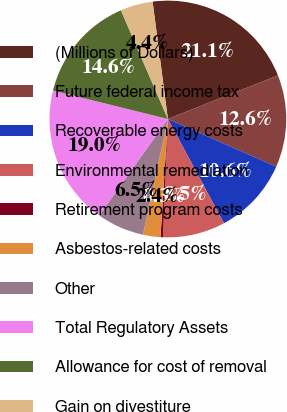Convert chart. <chart><loc_0><loc_0><loc_500><loc_500><pie_chart><fcel>(Millions of Dollars)<fcel>Future federal income tax<fcel>Recoverable energy costs<fcel>Environmental remediation<fcel>Retirement program costs<fcel>Asbestos-related costs<fcel>Other<fcel>Total Regulatory Assets<fcel>Allowance for cost of removal<fcel>Gain on divestiture<nl><fcel>21.06%<fcel>12.59%<fcel>10.55%<fcel>8.51%<fcel>0.34%<fcel>2.38%<fcel>6.47%<fcel>19.02%<fcel>14.64%<fcel>4.43%<nl></chart> 